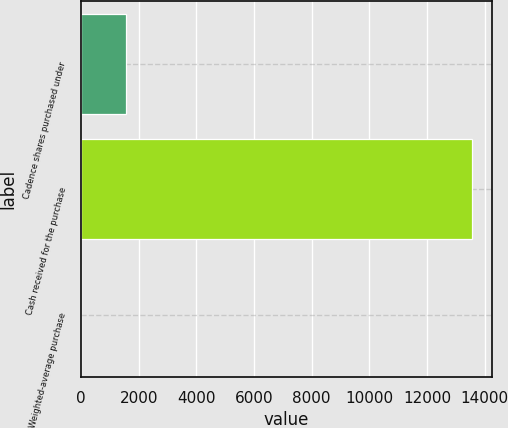<chart> <loc_0><loc_0><loc_500><loc_500><bar_chart><fcel>Cadence shares purchased under<fcel>Cash received for the purchase<fcel>Weighted-average purchase<nl><fcel>1548<fcel>13568<fcel>8.77<nl></chart> 